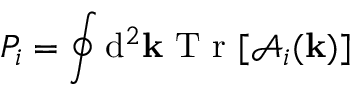<formula> <loc_0><loc_0><loc_500><loc_500>P _ { i } = \oint d ^ { 2 } { k } T r [ \mathcal { A } _ { i } ( { k } ) ]</formula> 